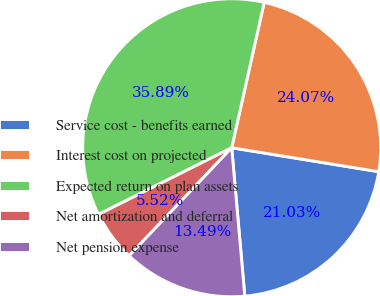Convert chart. <chart><loc_0><loc_0><loc_500><loc_500><pie_chart><fcel>Service cost - benefits earned<fcel>Interest cost on projected<fcel>Expected return on plan assets<fcel>Net amortization and deferral<fcel>Net pension expense<nl><fcel>21.03%<fcel>24.07%<fcel>35.89%<fcel>5.52%<fcel>13.49%<nl></chart> 